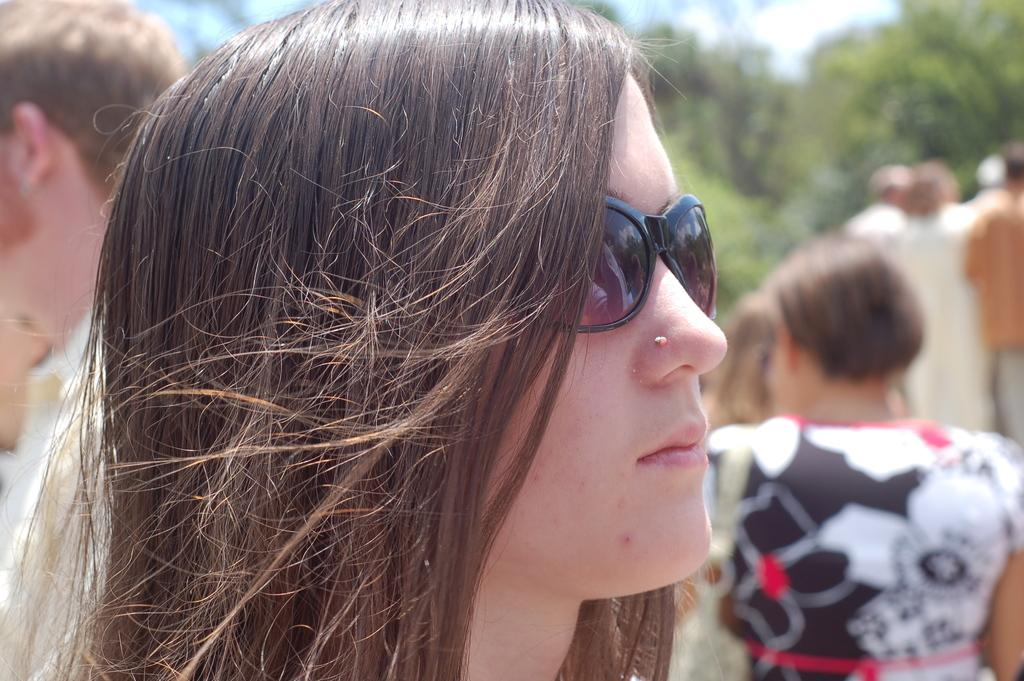What is the main subject in the foreground of the image? There is a woman with goggles in the foreground of the image. What can be seen in the background of the image? There is a group of people in the background of the image. What type of natural environment is visible in the image? Trees are visible in the image. What is visible at the top of the image? The sky is visible at the top of the image. What type of teeth can be seen in the image? There are no teeth visible in the image. 